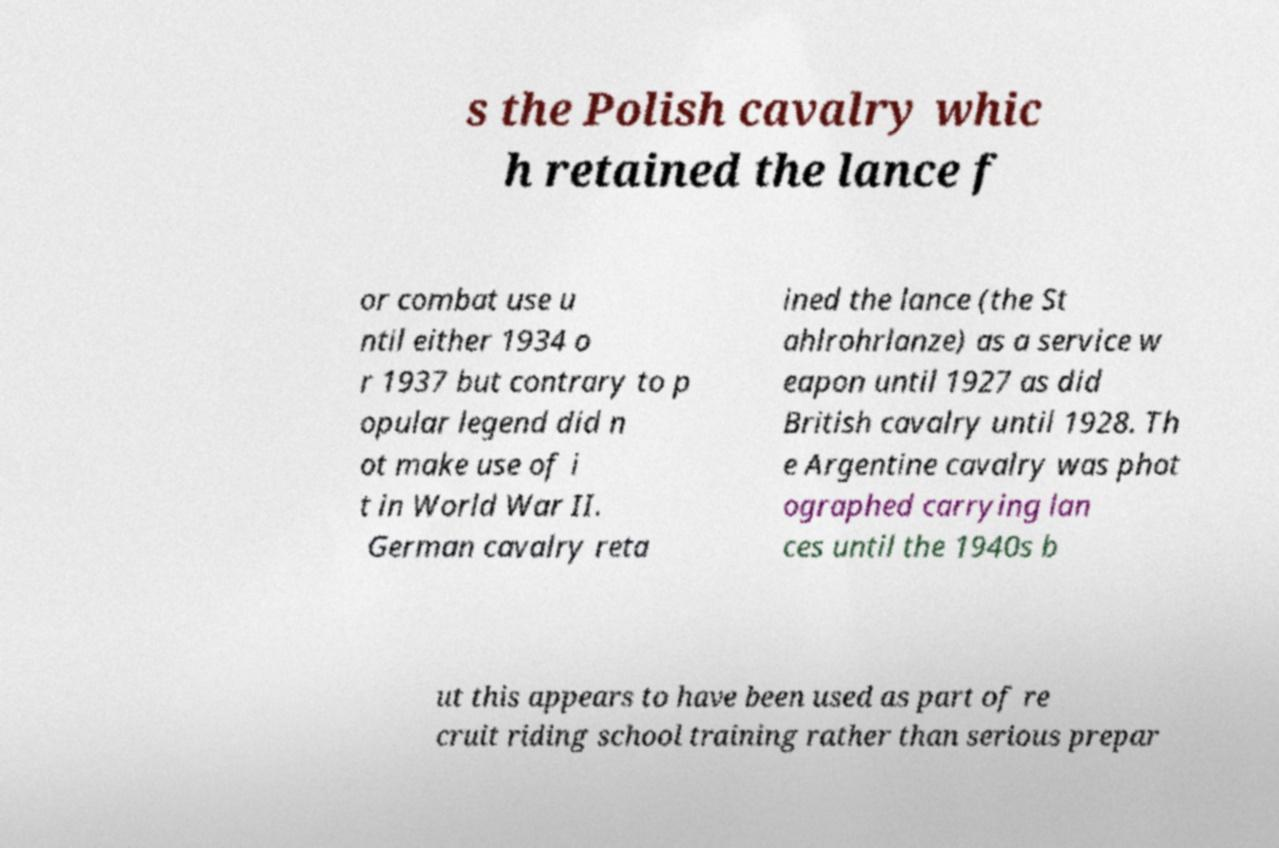Can you read and provide the text displayed in the image?This photo seems to have some interesting text. Can you extract and type it out for me? s the Polish cavalry whic h retained the lance f or combat use u ntil either 1934 o r 1937 but contrary to p opular legend did n ot make use of i t in World War II. German cavalry reta ined the lance (the St ahlrohrlanze) as a service w eapon until 1927 as did British cavalry until 1928. Th e Argentine cavalry was phot ographed carrying lan ces until the 1940s b ut this appears to have been used as part of re cruit riding school training rather than serious prepar 